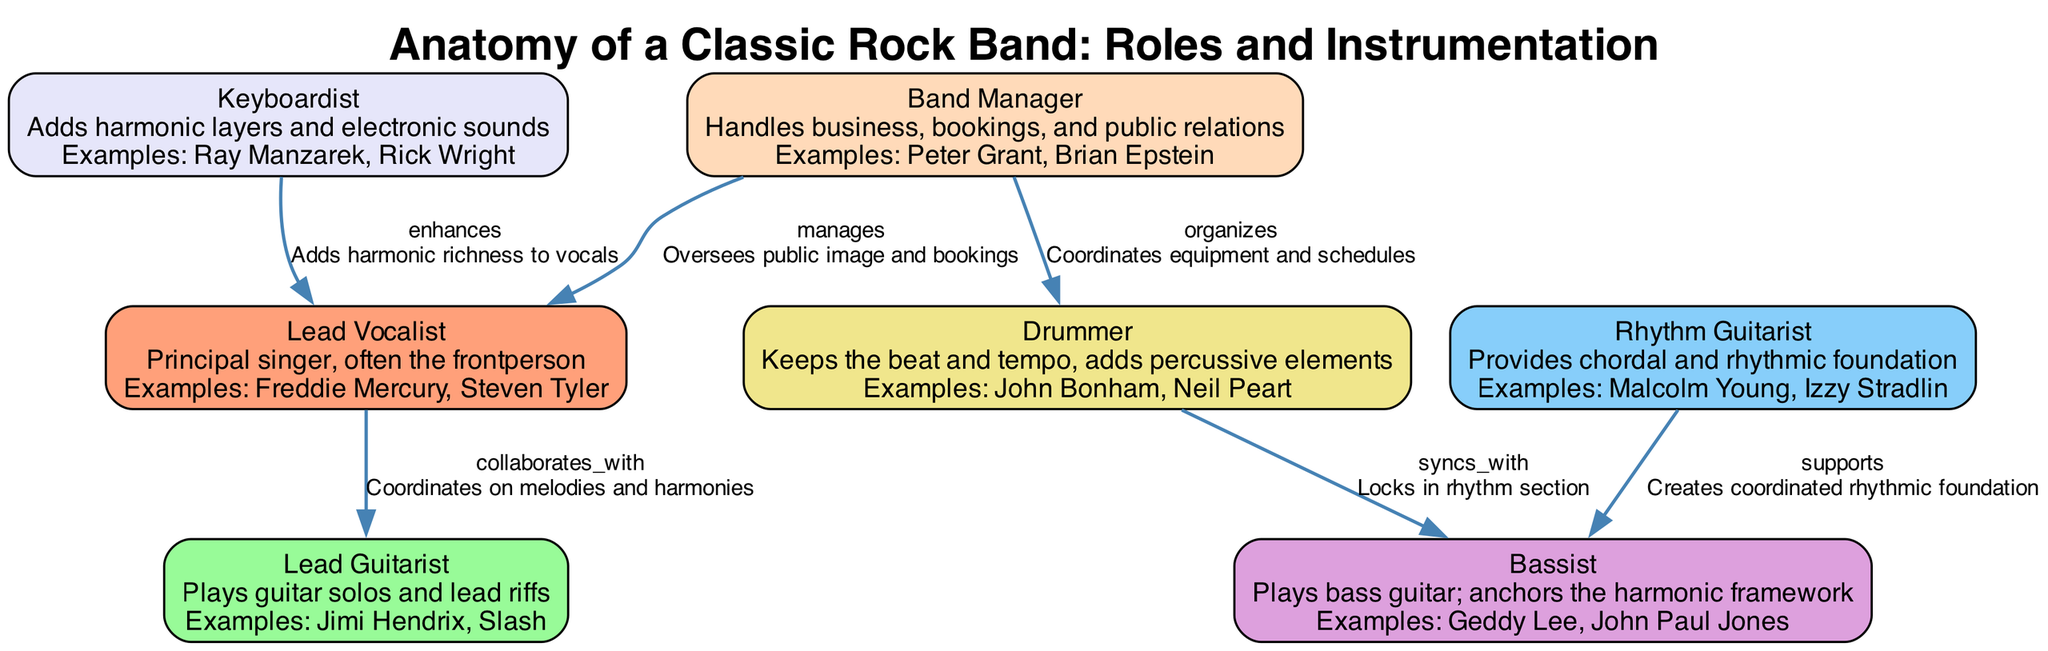What is the role of the 'Lead Vocalist'? The 'Lead Vocalist' is defined in the diagram as the principal singer and often the frontperson of the band. The role emphasizes their responsibility as the main performer and voice of the band.
Answer: Principal singer Who collaborates with the 'Bassist'? According to the diagram, the 'Rhythm Guitarist' collaborates with the 'Bassist'. The relationship is depicted through the connection between these two roles, indicating they work in tandem to create the rhythmic foundation of the music.
Answer: Rhythm Guitarist How many nodes are in the diagram? The diagram lists seven distinct roles as nodes: Lead Vocalist, Lead Guitarist, Rhythm Guitarist, Bassist, Drummer, Keyboardist, and Band Manager. Counting each of these roles results in a total of seven nodes represented in the diagram.
Answer: 7 What is the relationship between the 'Vocalist' and the 'Guitarist'? The diagram states that the relationship between the 'Vocalist' and the 'Guitarist' is categorized as "collaborates_with," which illustrates that these two roles coordinate on melodies and harmonies, enhancing their combined musical output.
Answer: collaborates_with Which role adds harmonic richness to vocals? The 'Keyboardist' is explicitly noted in the diagram as the role that enhances the vocals, adding harmonic richness to the overall sound of the band. This relationship highlights how different instruments contribute to the band’s musical texture.
Answer: Keyboardist In what way does the 'Manager' interact with the 'Vocalist'? In the diagram, the 'Manager' is said to "manages" the 'Vocalist', meaning this role oversees the public image and bookings for the vocalist, indicating an administrative and supportive relationship that is crucial for the band’s image.
Answer: manages What duties does the 'Manager' perform for the 'Drummer'? The diagram illustrates that the 'Manager' "organizes" tasks for the 'Drummer'. This means the manager is responsible for coordinating equipment and schedules, which is essential for the practical aspects of the drummer's role in the band.
Answer: organizes Which role anchors the harmonic framework? The diagram specifies that the 'Bassist' plays this essential role within the band. By anchoring the harmonic framework, the bassist contributes significant depth and foundation to the band’s music.
Answer: Bassist 